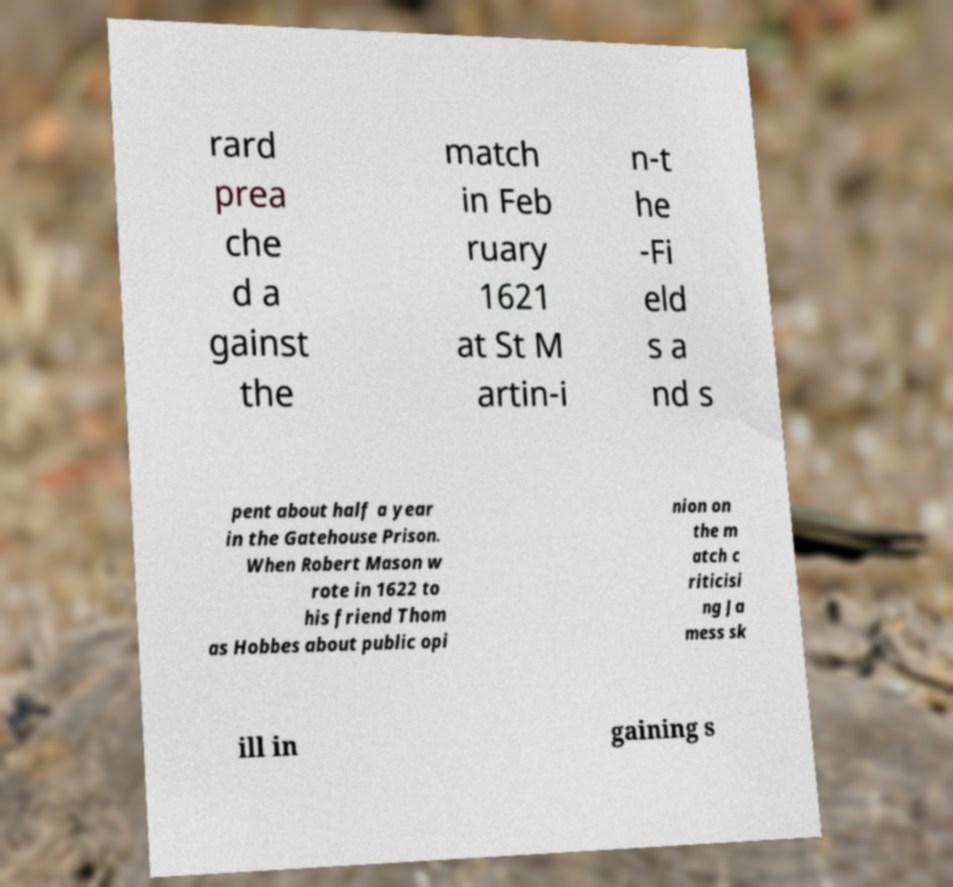There's text embedded in this image that I need extracted. Can you transcribe it verbatim? rard prea che d a gainst the match in Feb ruary 1621 at St M artin-i n-t he -Fi eld s a nd s pent about half a year in the Gatehouse Prison. When Robert Mason w rote in 1622 to his friend Thom as Hobbes about public opi nion on the m atch c riticisi ng Ja mess sk ill in gaining s 